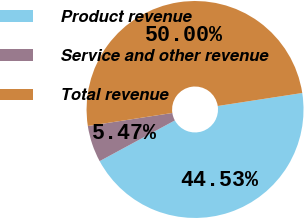Convert chart to OTSL. <chart><loc_0><loc_0><loc_500><loc_500><pie_chart><fcel>Product revenue<fcel>Service and other revenue<fcel>Total revenue<nl><fcel>44.53%<fcel>5.47%<fcel>50.0%<nl></chart> 